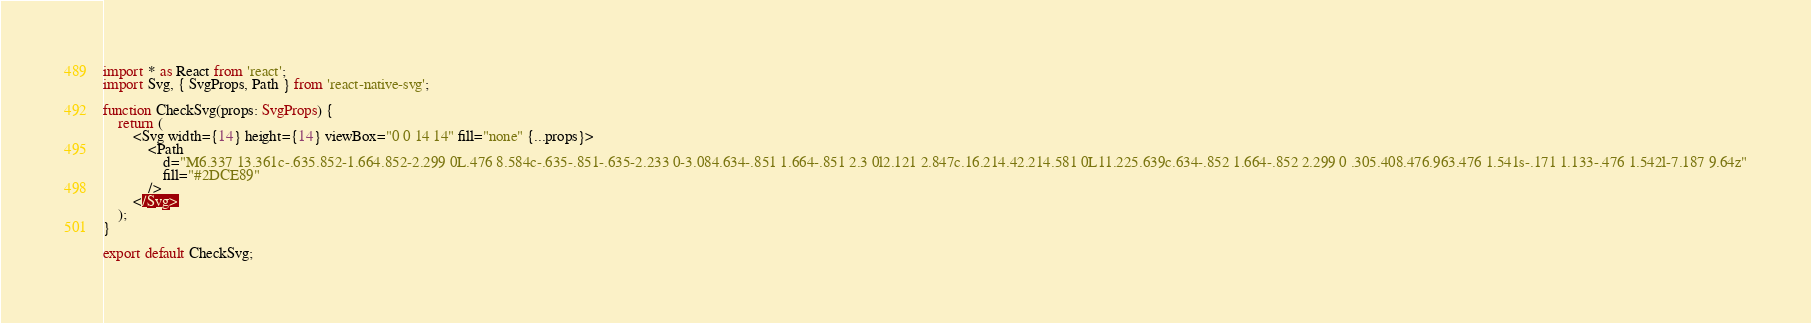Convert code to text. <code><loc_0><loc_0><loc_500><loc_500><_TypeScript_>import * as React from 'react';
import Svg, { SvgProps, Path } from 'react-native-svg';

function CheckSvg(props: SvgProps) {
    return (
        <Svg width={14} height={14} viewBox="0 0 14 14" fill="none" {...props}>
            <Path
                d="M6.337 13.361c-.635.852-1.664.852-2.299 0L.476 8.584c-.635-.851-.635-2.233 0-3.084.634-.851 1.664-.851 2.3 0l2.121 2.847c.16.214.42.214.581 0L11.225.639c.634-.852 1.664-.852 2.299 0 .305.408.476.963.476 1.541s-.171 1.133-.476 1.542l-7.187 9.64z"
                fill="#2DCE89"
            />
        </Svg>
    );
}

export default CheckSvg;
</code> 